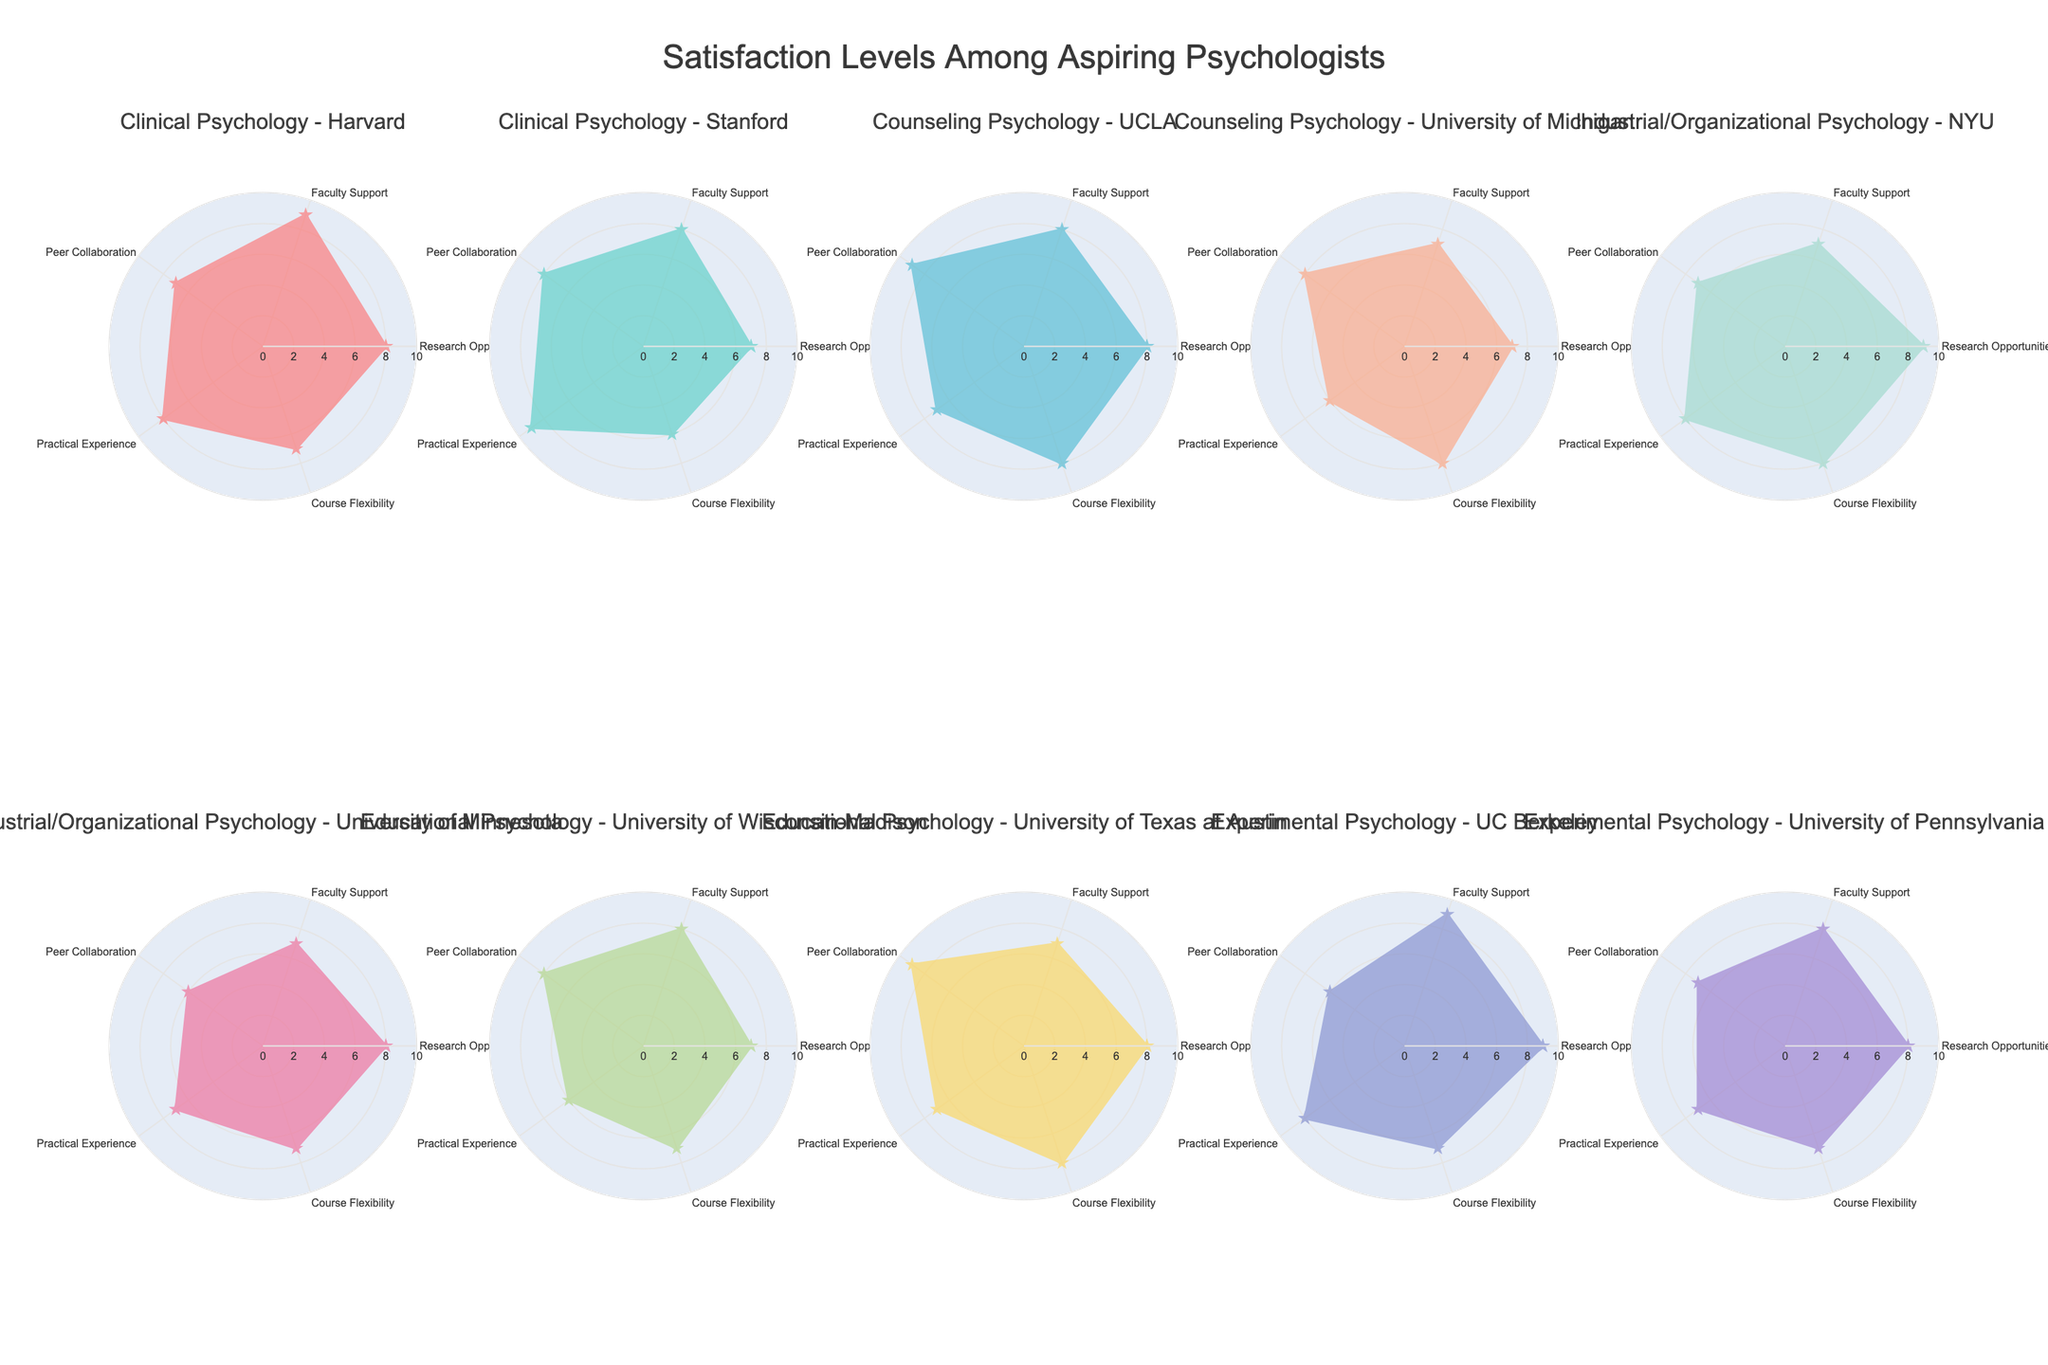what is the main title of the figure? The title of the figure is typically found at the top and is a textual representation that describes the whole chart. Here, it indicates that the figure shows the "Satisfaction Levels Among Aspiring Psychologists".
Answer: Satisfaction Levels Among Aspiring Psychologists Which program shows the highest value in Research Opportunities? Check for the wedge that reaches furthest along the 'Research Opportunities' axis. The highest value corresponds to Experimental Psychology - UC Berkeley, which has a value of 9.
Answer: Experimental Psychology - UC Berkeley How many categories are being evaluated for each program? The radar chart evaluates each program across different dimensions, which can be counted directly from the visual representation. Here, there are six categories: Research Opportunities, Faculty Support, Peer Collaboration, Practical Experience, Course Flexibility, and Overall Satisfaction.
Answer: 6 Which program has the lowest overall satisfaction? To find which program has the lowest overall satisfaction, look for the shortest wedge on the 'Overall Satisfaction' axis. This program is shown as Clinical Psychology - Stanford with a value of 7.
Answer: Clinical Psychology - Stanford Compare the Practical Experience scores between Clinical Psychology - Stanford and Counseling Psychology - UCLA. Locate the Practical Experience scores on the radar charts for both programs and compare them. Counseling Psychology - UCLA has a score of 7 and Clinical Psychology - Stanford has a score of 9.
Answer: Clinical Psychology - Stanford is higher What is the average score for Faculty Support across all programs? Add the Faculty Support values for all programs and divide by the number of programs (10). The sum is (9+8+8+7+7+7+8+7+9+8) = 78; therefore, the average is 78 / 10.
Answer: 7.8 What scores does Industrial/Organizational Psychology - NYU have on Peer Collaboration and Research Opportunities? Identify the appropriate wedges on the radar chart for Industrial/Organizational Psychology - NYU. It scores 7 on Peer Collaboration and 9 on Research Opportunities.
Answer: 7 and 9 respectively Which educational program has the most consistent scores across all categories? Look for the radar chart where the score wedges are almost equally distant from the center across all categories. Counseling Psychology - UCLA seems the most consistent, with most scores around 8.
Answer: Counseling Psychology - UCLA Is there any program that has the highest value in more than one category? Examine each category to check if any program's wedge extends to the maximum value more than once. Experimental Psychology - UC Berkeley has the highest in Research Opportunities and Faculty Support.
Answer: Experimental Psychology - UC Berkeley 